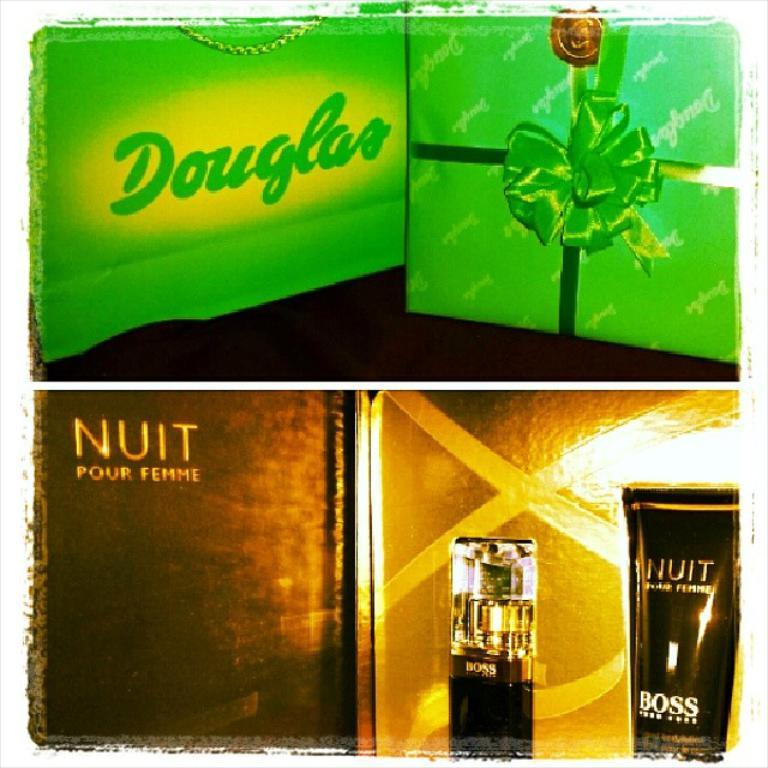<image>
Share a concise interpretation of the image provided. Cologne boxes of different scents including Boss and Nuit. 